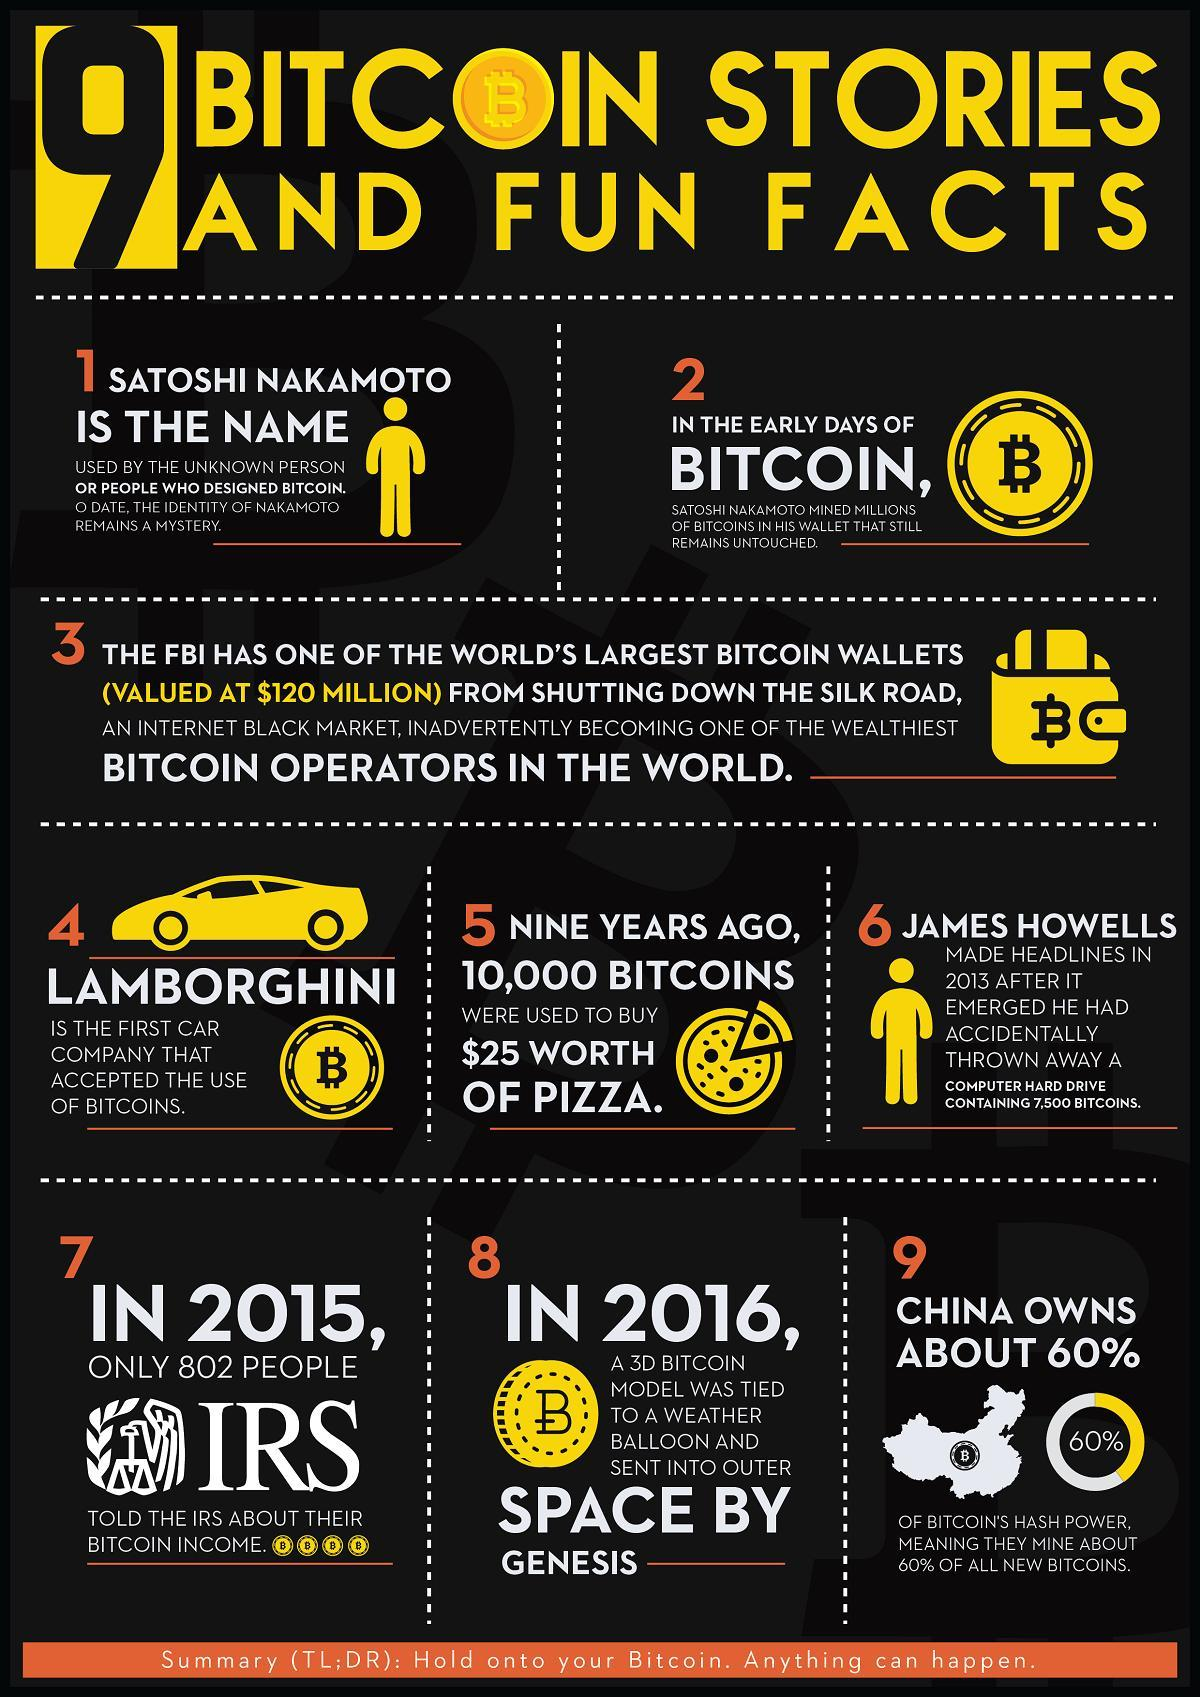from where did FBI get the bitcoin wallet
Answer the question with a short phrase. the silk road which country mines the major share of bitcoins China who sent a 3D bitcoin model to outer space genesis what was the equivalent of $25 worth of Pizza 10,000 bitcoins 